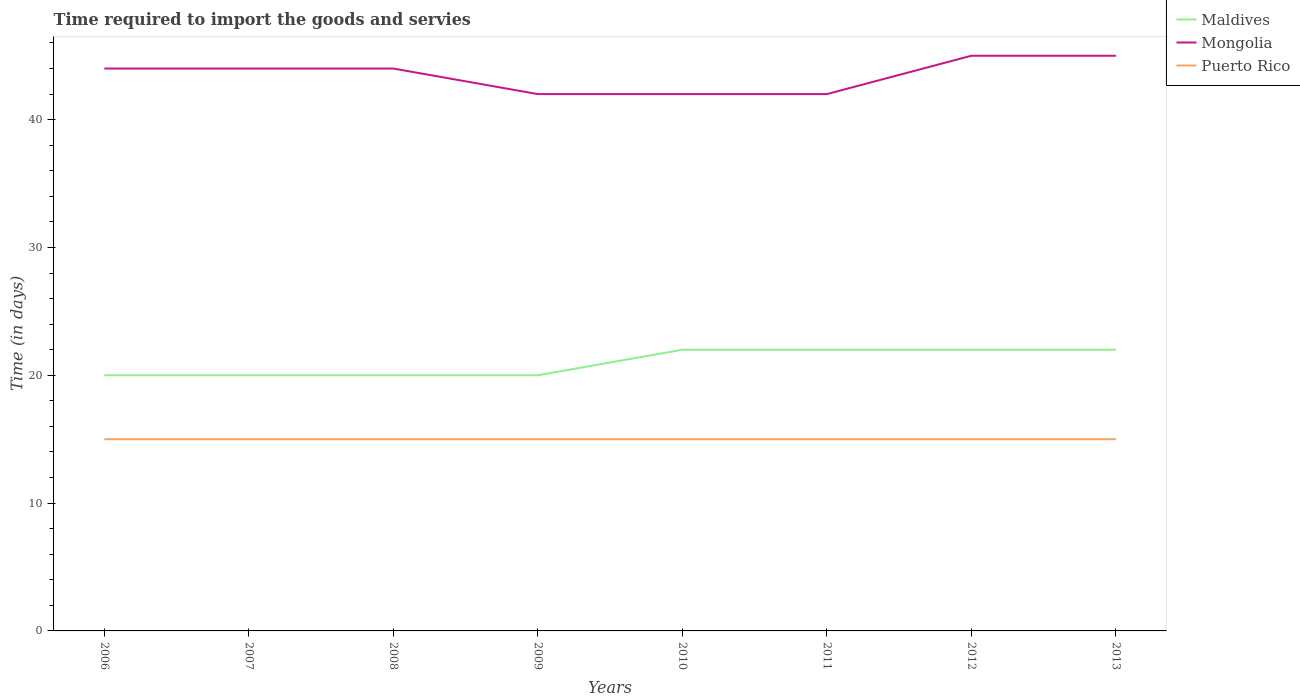How many different coloured lines are there?
Provide a succinct answer. 3. Does the line corresponding to Puerto Rico intersect with the line corresponding to Maldives?
Your answer should be very brief. No. Across all years, what is the maximum number of days required to import the goods and services in Maldives?
Offer a very short reply. 20. In which year was the number of days required to import the goods and services in Maldives maximum?
Provide a short and direct response. 2006. What is the total number of days required to import the goods and services in Mongolia in the graph?
Provide a short and direct response. 0. What is the difference between the highest and the second highest number of days required to import the goods and services in Maldives?
Make the answer very short. 2. Does the graph contain any zero values?
Your response must be concise. No. Where does the legend appear in the graph?
Offer a terse response. Top right. How many legend labels are there?
Your response must be concise. 3. How are the legend labels stacked?
Your answer should be compact. Vertical. What is the title of the graph?
Give a very brief answer. Time required to import the goods and servies. Does "European Union" appear as one of the legend labels in the graph?
Keep it short and to the point. No. What is the label or title of the Y-axis?
Offer a terse response. Time (in days). What is the Time (in days) of Mongolia in 2006?
Offer a very short reply. 44. What is the Time (in days) in Puerto Rico in 2006?
Offer a very short reply. 15. What is the Time (in days) of Mongolia in 2007?
Your response must be concise. 44. What is the Time (in days) in Maldives in 2008?
Provide a short and direct response. 20. What is the Time (in days) of Mongolia in 2008?
Give a very brief answer. 44. What is the Time (in days) in Puerto Rico in 2008?
Your answer should be compact. 15. What is the Time (in days) in Puerto Rico in 2009?
Provide a short and direct response. 15. What is the Time (in days) of Puerto Rico in 2010?
Your answer should be very brief. 15. What is the Time (in days) of Maldives in 2011?
Keep it short and to the point. 22. What is the Time (in days) of Puerto Rico in 2012?
Your answer should be compact. 15. What is the Time (in days) in Maldives in 2013?
Provide a short and direct response. 22. What is the Time (in days) of Puerto Rico in 2013?
Ensure brevity in your answer.  15. Across all years, what is the maximum Time (in days) in Mongolia?
Ensure brevity in your answer.  45. Across all years, what is the maximum Time (in days) of Puerto Rico?
Your answer should be very brief. 15. Across all years, what is the minimum Time (in days) in Mongolia?
Your response must be concise. 42. What is the total Time (in days) in Maldives in the graph?
Offer a very short reply. 168. What is the total Time (in days) of Mongolia in the graph?
Ensure brevity in your answer.  348. What is the total Time (in days) in Puerto Rico in the graph?
Your response must be concise. 120. What is the difference between the Time (in days) in Mongolia in 2006 and that in 2007?
Ensure brevity in your answer.  0. What is the difference between the Time (in days) of Maldives in 2006 and that in 2008?
Provide a short and direct response. 0. What is the difference between the Time (in days) of Mongolia in 2006 and that in 2008?
Your answer should be very brief. 0. What is the difference between the Time (in days) in Puerto Rico in 2006 and that in 2008?
Make the answer very short. 0. What is the difference between the Time (in days) of Mongolia in 2006 and that in 2009?
Your response must be concise. 2. What is the difference between the Time (in days) of Puerto Rico in 2006 and that in 2009?
Provide a succinct answer. 0. What is the difference between the Time (in days) in Mongolia in 2006 and that in 2010?
Keep it short and to the point. 2. What is the difference between the Time (in days) in Maldives in 2006 and that in 2011?
Offer a very short reply. -2. What is the difference between the Time (in days) of Mongolia in 2006 and that in 2011?
Provide a short and direct response. 2. What is the difference between the Time (in days) in Maldives in 2006 and that in 2012?
Your response must be concise. -2. What is the difference between the Time (in days) of Maldives in 2006 and that in 2013?
Make the answer very short. -2. What is the difference between the Time (in days) of Mongolia in 2006 and that in 2013?
Ensure brevity in your answer.  -1. What is the difference between the Time (in days) in Maldives in 2007 and that in 2008?
Offer a terse response. 0. What is the difference between the Time (in days) in Puerto Rico in 2007 and that in 2008?
Keep it short and to the point. 0. What is the difference between the Time (in days) in Maldives in 2007 and that in 2009?
Provide a succinct answer. 0. What is the difference between the Time (in days) in Mongolia in 2007 and that in 2009?
Keep it short and to the point. 2. What is the difference between the Time (in days) of Puerto Rico in 2007 and that in 2009?
Offer a very short reply. 0. What is the difference between the Time (in days) of Maldives in 2007 and that in 2010?
Provide a succinct answer. -2. What is the difference between the Time (in days) in Mongolia in 2007 and that in 2011?
Ensure brevity in your answer.  2. What is the difference between the Time (in days) of Maldives in 2007 and that in 2012?
Ensure brevity in your answer.  -2. What is the difference between the Time (in days) of Puerto Rico in 2007 and that in 2012?
Offer a terse response. 0. What is the difference between the Time (in days) in Maldives in 2008 and that in 2009?
Ensure brevity in your answer.  0. What is the difference between the Time (in days) in Mongolia in 2008 and that in 2010?
Keep it short and to the point. 2. What is the difference between the Time (in days) of Maldives in 2008 and that in 2011?
Make the answer very short. -2. What is the difference between the Time (in days) in Maldives in 2008 and that in 2013?
Offer a terse response. -2. What is the difference between the Time (in days) of Puerto Rico in 2009 and that in 2010?
Your answer should be compact. 0. What is the difference between the Time (in days) in Maldives in 2009 and that in 2011?
Ensure brevity in your answer.  -2. What is the difference between the Time (in days) in Puerto Rico in 2009 and that in 2011?
Make the answer very short. 0. What is the difference between the Time (in days) in Mongolia in 2009 and that in 2012?
Your answer should be very brief. -3. What is the difference between the Time (in days) of Puerto Rico in 2009 and that in 2012?
Your response must be concise. 0. What is the difference between the Time (in days) of Maldives in 2009 and that in 2013?
Offer a very short reply. -2. What is the difference between the Time (in days) of Puerto Rico in 2009 and that in 2013?
Provide a short and direct response. 0. What is the difference between the Time (in days) in Puerto Rico in 2010 and that in 2011?
Ensure brevity in your answer.  0. What is the difference between the Time (in days) of Mongolia in 2010 and that in 2012?
Offer a very short reply. -3. What is the difference between the Time (in days) in Puerto Rico in 2010 and that in 2012?
Your response must be concise. 0. What is the difference between the Time (in days) in Maldives in 2010 and that in 2013?
Your answer should be compact. 0. What is the difference between the Time (in days) of Mongolia in 2011 and that in 2012?
Keep it short and to the point. -3. What is the difference between the Time (in days) of Puerto Rico in 2011 and that in 2012?
Give a very brief answer. 0. What is the difference between the Time (in days) in Maldives in 2011 and that in 2013?
Provide a short and direct response. 0. What is the difference between the Time (in days) of Maldives in 2006 and the Time (in days) of Mongolia in 2007?
Keep it short and to the point. -24. What is the difference between the Time (in days) in Maldives in 2006 and the Time (in days) in Puerto Rico in 2007?
Your answer should be compact. 5. What is the difference between the Time (in days) of Mongolia in 2006 and the Time (in days) of Puerto Rico in 2007?
Give a very brief answer. 29. What is the difference between the Time (in days) of Mongolia in 2006 and the Time (in days) of Puerto Rico in 2008?
Provide a short and direct response. 29. What is the difference between the Time (in days) of Maldives in 2006 and the Time (in days) of Puerto Rico in 2010?
Ensure brevity in your answer.  5. What is the difference between the Time (in days) in Mongolia in 2006 and the Time (in days) in Puerto Rico in 2010?
Provide a short and direct response. 29. What is the difference between the Time (in days) of Maldives in 2006 and the Time (in days) of Mongolia in 2011?
Provide a short and direct response. -22. What is the difference between the Time (in days) in Maldives in 2006 and the Time (in days) in Mongolia in 2012?
Provide a succinct answer. -25. What is the difference between the Time (in days) in Mongolia in 2006 and the Time (in days) in Puerto Rico in 2012?
Offer a terse response. 29. What is the difference between the Time (in days) in Maldives in 2006 and the Time (in days) in Puerto Rico in 2013?
Offer a terse response. 5. What is the difference between the Time (in days) of Mongolia in 2006 and the Time (in days) of Puerto Rico in 2013?
Your answer should be very brief. 29. What is the difference between the Time (in days) in Maldives in 2007 and the Time (in days) in Puerto Rico in 2008?
Give a very brief answer. 5. What is the difference between the Time (in days) of Maldives in 2007 and the Time (in days) of Mongolia in 2009?
Keep it short and to the point. -22. What is the difference between the Time (in days) of Maldives in 2007 and the Time (in days) of Puerto Rico in 2009?
Keep it short and to the point. 5. What is the difference between the Time (in days) of Mongolia in 2007 and the Time (in days) of Puerto Rico in 2009?
Your answer should be compact. 29. What is the difference between the Time (in days) in Maldives in 2007 and the Time (in days) in Mongolia in 2010?
Keep it short and to the point. -22. What is the difference between the Time (in days) in Maldives in 2007 and the Time (in days) in Puerto Rico in 2010?
Provide a short and direct response. 5. What is the difference between the Time (in days) of Mongolia in 2007 and the Time (in days) of Puerto Rico in 2010?
Your answer should be very brief. 29. What is the difference between the Time (in days) in Maldives in 2007 and the Time (in days) in Mongolia in 2011?
Ensure brevity in your answer.  -22. What is the difference between the Time (in days) in Maldives in 2007 and the Time (in days) in Puerto Rico in 2011?
Give a very brief answer. 5. What is the difference between the Time (in days) of Maldives in 2007 and the Time (in days) of Mongolia in 2012?
Make the answer very short. -25. What is the difference between the Time (in days) in Maldives in 2007 and the Time (in days) in Puerto Rico in 2012?
Provide a succinct answer. 5. What is the difference between the Time (in days) of Maldives in 2007 and the Time (in days) of Mongolia in 2013?
Make the answer very short. -25. What is the difference between the Time (in days) of Mongolia in 2007 and the Time (in days) of Puerto Rico in 2013?
Provide a short and direct response. 29. What is the difference between the Time (in days) of Mongolia in 2008 and the Time (in days) of Puerto Rico in 2009?
Keep it short and to the point. 29. What is the difference between the Time (in days) of Maldives in 2008 and the Time (in days) of Mongolia in 2010?
Offer a terse response. -22. What is the difference between the Time (in days) of Mongolia in 2008 and the Time (in days) of Puerto Rico in 2010?
Offer a terse response. 29. What is the difference between the Time (in days) of Maldives in 2008 and the Time (in days) of Mongolia in 2011?
Offer a very short reply. -22. What is the difference between the Time (in days) in Maldives in 2008 and the Time (in days) in Puerto Rico in 2011?
Your response must be concise. 5. What is the difference between the Time (in days) in Mongolia in 2008 and the Time (in days) in Puerto Rico in 2011?
Ensure brevity in your answer.  29. What is the difference between the Time (in days) of Mongolia in 2008 and the Time (in days) of Puerto Rico in 2012?
Your answer should be compact. 29. What is the difference between the Time (in days) in Maldives in 2008 and the Time (in days) in Mongolia in 2013?
Your response must be concise. -25. What is the difference between the Time (in days) in Maldives in 2009 and the Time (in days) in Puerto Rico in 2010?
Your answer should be very brief. 5. What is the difference between the Time (in days) of Mongolia in 2009 and the Time (in days) of Puerto Rico in 2010?
Your answer should be very brief. 27. What is the difference between the Time (in days) of Maldives in 2009 and the Time (in days) of Puerto Rico in 2011?
Your answer should be very brief. 5. What is the difference between the Time (in days) in Mongolia in 2009 and the Time (in days) in Puerto Rico in 2011?
Ensure brevity in your answer.  27. What is the difference between the Time (in days) in Maldives in 2009 and the Time (in days) in Mongolia in 2012?
Your answer should be very brief. -25. What is the difference between the Time (in days) in Maldives in 2009 and the Time (in days) in Puerto Rico in 2012?
Provide a short and direct response. 5. What is the difference between the Time (in days) in Maldives in 2009 and the Time (in days) in Mongolia in 2013?
Offer a very short reply. -25. What is the difference between the Time (in days) in Maldives in 2010 and the Time (in days) in Mongolia in 2011?
Keep it short and to the point. -20. What is the difference between the Time (in days) in Mongolia in 2010 and the Time (in days) in Puerto Rico in 2013?
Provide a succinct answer. 27. What is the difference between the Time (in days) in Maldives in 2011 and the Time (in days) in Puerto Rico in 2012?
Your answer should be compact. 7. What is the difference between the Time (in days) of Mongolia in 2011 and the Time (in days) of Puerto Rico in 2012?
Offer a terse response. 27. What is the difference between the Time (in days) in Maldives in 2011 and the Time (in days) in Puerto Rico in 2013?
Offer a very short reply. 7. What is the difference between the Time (in days) in Mongolia in 2011 and the Time (in days) in Puerto Rico in 2013?
Provide a succinct answer. 27. What is the difference between the Time (in days) of Maldives in 2012 and the Time (in days) of Puerto Rico in 2013?
Give a very brief answer. 7. What is the difference between the Time (in days) in Mongolia in 2012 and the Time (in days) in Puerto Rico in 2013?
Your response must be concise. 30. What is the average Time (in days) in Maldives per year?
Offer a terse response. 21. What is the average Time (in days) in Mongolia per year?
Your answer should be compact. 43.5. What is the average Time (in days) in Puerto Rico per year?
Give a very brief answer. 15. In the year 2006, what is the difference between the Time (in days) of Maldives and Time (in days) of Puerto Rico?
Make the answer very short. 5. In the year 2006, what is the difference between the Time (in days) of Mongolia and Time (in days) of Puerto Rico?
Provide a short and direct response. 29. In the year 2007, what is the difference between the Time (in days) in Maldives and Time (in days) in Mongolia?
Your response must be concise. -24. In the year 2008, what is the difference between the Time (in days) in Mongolia and Time (in days) in Puerto Rico?
Provide a short and direct response. 29. In the year 2009, what is the difference between the Time (in days) in Maldives and Time (in days) in Mongolia?
Provide a short and direct response. -22. In the year 2010, what is the difference between the Time (in days) of Maldives and Time (in days) of Puerto Rico?
Your response must be concise. 7. In the year 2012, what is the difference between the Time (in days) of Maldives and Time (in days) of Mongolia?
Offer a terse response. -23. In the year 2012, what is the difference between the Time (in days) in Maldives and Time (in days) in Puerto Rico?
Provide a succinct answer. 7. What is the ratio of the Time (in days) in Maldives in 2006 to that in 2007?
Provide a short and direct response. 1. What is the ratio of the Time (in days) of Mongolia in 2006 to that in 2007?
Offer a very short reply. 1. What is the ratio of the Time (in days) of Maldives in 2006 to that in 2008?
Keep it short and to the point. 1. What is the ratio of the Time (in days) of Mongolia in 2006 to that in 2008?
Ensure brevity in your answer.  1. What is the ratio of the Time (in days) in Mongolia in 2006 to that in 2009?
Keep it short and to the point. 1.05. What is the ratio of the Time (in days) of Mongolia in 2006 to that in 2010?
Your answer should be compact. 1.05. What is the ratio of the Time (in days) of Maldives in 2006 to that in 2011?
Give a very brief answer. 0.91. What is the ratio of the Time (in days) of Mongolia in 2006 to that in 2011?
Your answer should be compact. 1.05. What is the ratio of the Time (in days) in Maldives in 2006 to that in 2012?
Keep it short and to the point. 0.91. What is the ratio of the Time (in days) of Mongolia in 2006 to that in 2012?
Provide a short and direct response. 0.98. What is the ratio of the Time (in days) in Mongolia in 2006 to that in 2013?
Offer a terse response. 0.98. What is the ratio of the Time (in days) in Puerto Rico in 2006 to that in 2013?
Make the answer very short. 1. What is the ratio of the Time (in days) in Maldives in 2007 to that in 2008?
Provide a succinct answer. 1. What is the ratio of the Time (in days) in Mongolia in 2007 to that in 2008?
Provide a succinct answer. 1. What is the ratio of the Time (in days) of Puerto Rico in 2007 to that in 2008?
Offer a very short reply. 1. What is the ratio of the Time (in days) in Mongolia in 2007 to that in 2009?
Offer a very short reply. 1.05. What is the ratio of the Time (in days) in Puerto Rico in 2007 to that in 2009?
Your response must be concise. 1. What is the ratio of the Time (in days) of Mongolia in 2007 to that in 2010?
Give a very brief answer. 1.05. What is the ratio of the Time (in days) in Maldives in 2007 to that in 2011?
Offer a terse response. 0.91. What is the ratio of the Time (in days) of Mongolia in 2007 to that in 2011?
Make the answer very short. 1.05. What is the ratio of the Time (in days) of Maldives in 2007 to that in 2012?
Offer a very short reply. 0.91. What is the ratio of the Time (in days) of Mongolia in 2007 to that in 2012?
Ensure brevity in your answer.  0.98. What is the ratio of the Time (in days) of Puerto Rico in 2007 to that in 2012?
Provide a short and direct response. 1. What is the ratio of the Time (in days) in Mongolia in 2007 to that in 2013?
Provide a short and direct response. 0.98. What is the ratio of the Time (in days) in Maldives in 2008 to that in 2009?
Ensure brevity in your answer.  1. What is the ratio of the Time (in days) in Mongolia in 2008 to that in 2009?
Ensure brevity in your answer.  1.05. What is the ratio of the Time (in days) in Mongolia in 2008 to that in 2010?
Keep it short and to the point. 1.05. What is the ratio of the Time (in days) of Mongolia in 2008 to that in 2011?
Provide a succinct answer. 1.05. What is the ratio of the Time (in days) in Mongolia in 2008 to that in 2012?
Keep it short and to the point. 0.98. What is the ratio of the Time (in days) of Puerto Rico in 2008 to that in 2012?
Offer a very short reply. 1. What is the ratio of the Time (in days) of Mongolia in 2008 to that in 2013?
Offer a very short reply. 0.98. What is the ratio of the Time (in days) in Maldives in 2009 to that in 2010?
Your answer should be compact. 0.91. What is the ratio of the Time (in days) of Puerto Rico in 2009 to that in 2010?
Keep it short and to the point. 1. What is the ratio of the Time (in days) of Maldives in 2009 to that in 2011?
Your answer should be very brief. 0.91. What is the ratio of the Time (in days) in Mongolia in 2009 to that in 2011?
Offer a terse response. 1. What is the ratio of the Time (in days) of Puerto Rico in 2009 to that in 2011?
Make the answer very short. 1. What is the ratio of the Time (in days) in Mongolia in 2009 to that in 2012?
Provide a succinct answer. 0.93. What is the ratio of the Time (in days) in Maldives in 2009 to that in 2013?
Offer a very short reply. 0.91. What is the ratio of the Time (in days) of Maldives in 2010 to that in 2011?
Give a very brief answer. 1. What is the ratio of the Time (in days) in Mongolia in 2010 to that in 2011?
Keep it short and to the point. 1. What is the ratio of the Time (in days) of Mongolia in 2010 to that in 2012?
Your response must be concise. 0.93. What is the ratio of the Time (in days) of Puerto Rico in 2010 to that in 2012?
Your answer should be very brief. 1. What is the ratio of the Time (in days) in Mongolia in 2010 to that in 2013?
Your response must be concise. 0.93. What is the ratio of the Time (in days) of Puerto Rico in 2010 to that in 2013?
Provide a succinct answer. 1. What is the ratio of the Time (in days) of Maldives in 2011 to that in 2012?
Offer a very short reply. 1. What is the ratio of the Time (in days) of Mongolia in 2011 to that in 2012?
Give a very brief answer. 0.93. What is the ratio of the Time (in days) in Maldives in 2011 to that in 2013?
Offer a very short reply. 1. What is the ratio of the Time (in days) of Maldives in 2012 to that in 2013?
Ensure brevity in your answer.  1. What is the difference between the highest and the second highest Time (in days) of Maldives?
Offer a very short reply. 0. What is the difference between the highest and the second highest Time (in days) in Puerto Rico?
Your answer should be very brief. 0. 